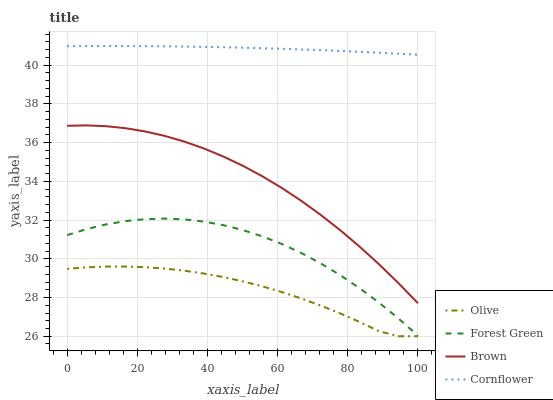Does Olive have the minimum area under the curve?
Answer yes or no. Yes. Does Cornflower have the maximum area under the curve?
Answer yes or no. Yes. Does Brown have the minimum area under the curve?
Answer yes or no. No. Does Brown have the maximum area under the curve?
Answer yes or no. No. Is Cornflower the smoothest?
Answer yes or no. Yes. Is Forest Green the roughest?
Answer yes or no. Yes. Is Brown the smoothest?
Answer yes or no. No. Is Brown the roughest?
Answer yes or no. No. Does Olive have the lowest value?
Answer yes or no. Yes. Does Brown have the lowest value?
Answer yes or no. No. Does Cornflower have the highest value?
Answer yes or no. Yes. Does Brown have the highest value?
Answer yes or no. No. Is Forest Green less than Brown?
Answer yes or no. Yes. Is Brown greater than Olive?
Answer yes or no. Yes. Does Forest Green intersect Brown?
Answer yes or no. No. 